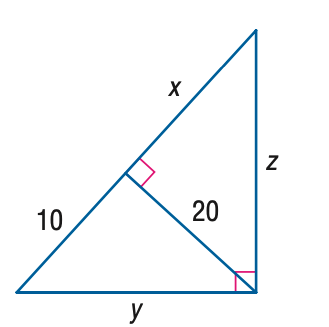Answer the mathemtical geometry problem and directly provide the correct option letter.
Question: Find y.
Choices: A: 10 B: 10 \sqrt { 3 } C: 20 D: 10 \sqrt { 5 } D 